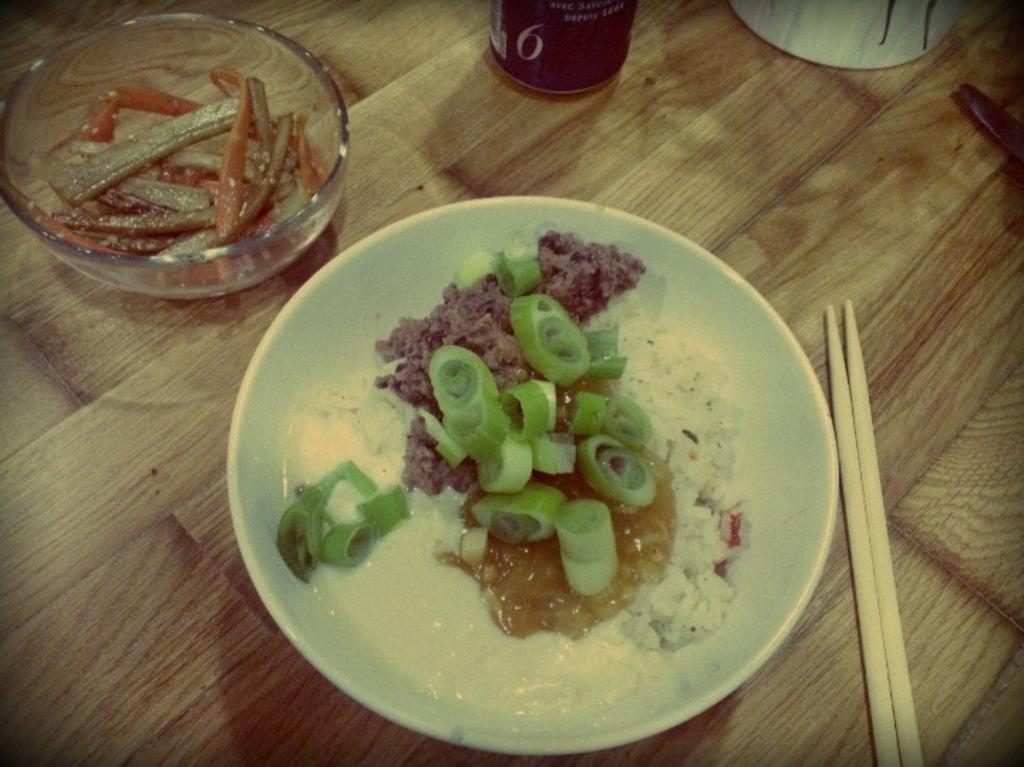What is placed in the bowls in the image? There are eatables placed in two bowls in the image. What utensils are placed beside the bowls? There are two chopsticks placed beside the bowls. Can you describe any other objects visible in the background? Unfortunately, the provided facts do not give any information about objects visible in the background. What type of fruit is hanging from the hook in the image? There is no hook or fruit present in the image. What time is displayed on the clock in the image? There is no clock present in the image. 